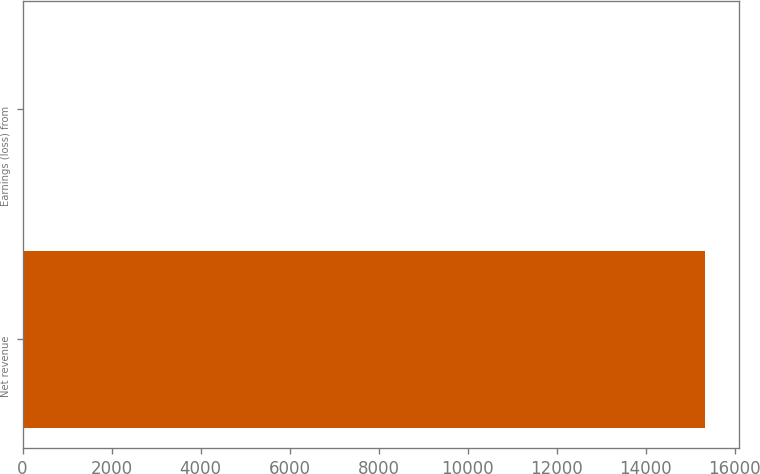Convert chart. <chart><loc_0><loc_0><loc_500><loc_500><bar_chart><fcel>Net revenue<fcel>Earnings (loss) from<nl><fcel>15337<fcel>2<nl></chart> 